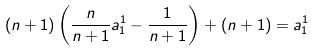Convert formula to latex. <formula><loc_0><loc_0><loc_500><loc_500>( n + 1 ) \left ( \frac { n } { n + 1 } a ^ { 1 } _ { 1 } - \frac { 1 } { n + 1 } \right ) + ( n + 1 ) = a ^ { 1 } _ { 1 }</formula> 